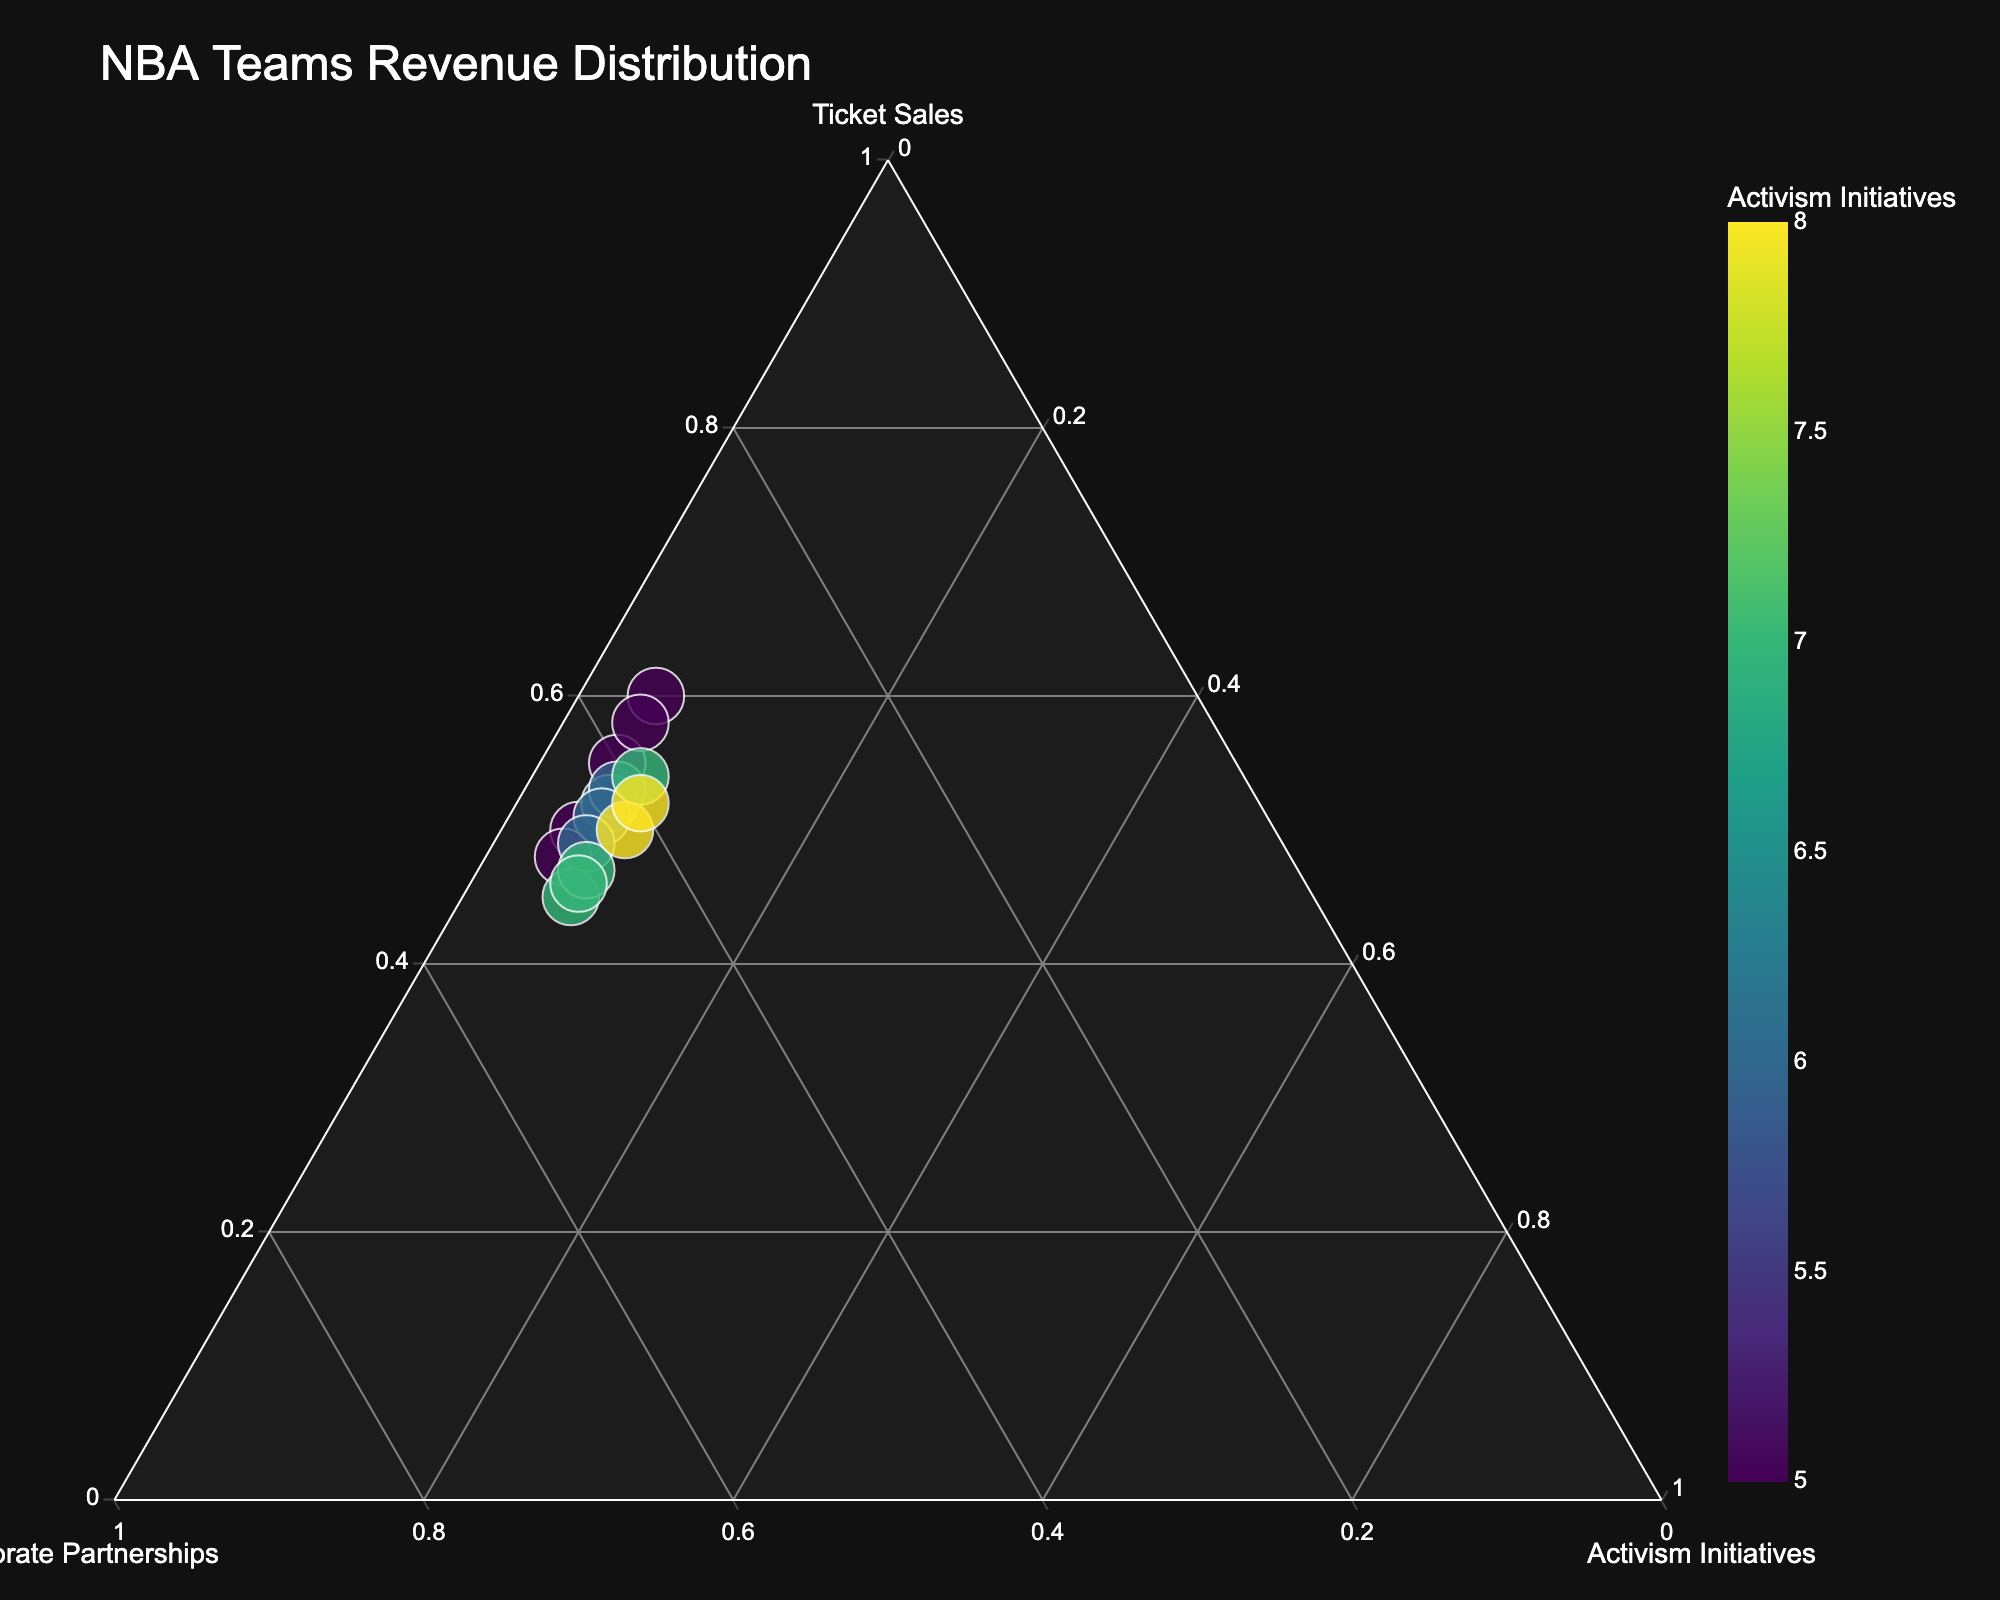What is the title of the ternary plot? The title is displayed at the top of the figure and gives an overview of the subject matter.
Answer: NBA Teams Revenue Distribution Which NBA team has the highest percentage of revenue from activism initiatives? Examine the color scale or the axis corresponding to activism initiatives to find the team with the highest percentage.
Answer: Denver Nuggets How are the axes labeled? The labels for the axes are generally positioned along the corners. Look for the textual labels around the triangle.
Answer: Ticket Sales, Corporate Partnerships, Activism Initiatives Which team has the largest total revenue? Refer to the size of the markers; larger markers indicate higher total revenue. Identify the largest marker in the plot.
Answer: Houston Rockets What is the average percentage of corporate partnerships across all teams? Calculate the corporate partnerships percentage from the data table, sum them up, and divide by the number of teams: (35+40+45+37+42+47+41+43+45+48+39+46+42+47+40)/15
Answer: 42.4 Is there a correlation between high ticket sales and activism initiatives? Observe positional trends in the ternary plot, particularly clusters along the Ticket Sales and Activism Initiatives corners.
Answer: No strong correlation Which team has the most balanced revenue distribution among ticket sales, corporate partnerships, and activism initiatives? Look for teams positioned nearer to the centroid of the ternary plot, indicating a balanced allocation across all three sources.
Answer: San Antonio Spurs Compare the Boston Celtics and Miami Heat in terms of corporate partnerships revenue percentage. Which team has a higher percentage? Refer to the positions of the markers for both teams along the Corporate Partnerships axis to determine which is higher.
Answer: Miami Heat How do the Philadelphia 76ers rank in terms of activism initiatives compared to other teams? Check the team's position and color coding along the Activism Initiatives axis to see their relative standing.
Answer: Approximately in the middle What trend can you observe regarding the size of the markers and the percentage revenue from activism initiatives? Examine any visible pattern or lack thereof where marker sizes increase or decrease with the percentage from activism initiatives.
Answer: Larger markers tend to have lower activism initiatives percentages 